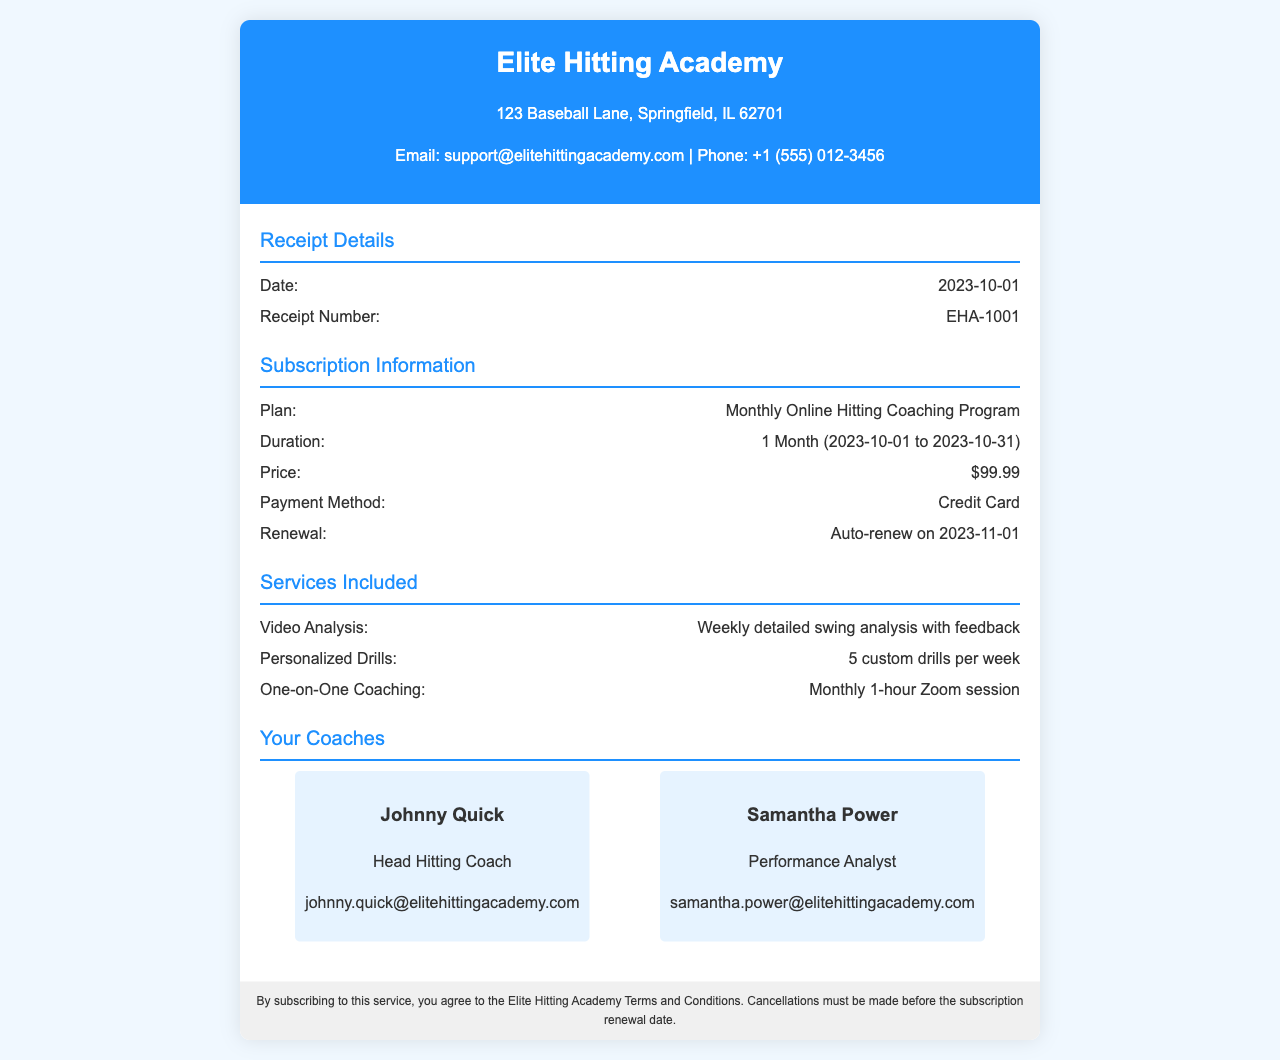what is the name of the academy? The academy's name is prominently displayed in the header section of the document.
Answer: Elite Hitting Academy what is the date of the receipt? The date can be found in the Receipt Details section of the document.
Answer: 2023-10-01 how much is the subscription price? The subscription price is listed under the Subscription Information section.
Answer: $99.99 who is the head hitting coach? The name of the head hitting coach is found in the Your Coaches section.
Answer: Johnny Quick what is included in the video analysis? The details about the video analysis are mentioned in the Services Included section.
Answer: Weekly detailed swing analysis with feedback how long is the subscription duration? The subscription duration is specified in the Subscription Information section.
Answer: 1 Month (2023-10-01 to 2023-10-31) what type of payment method is used? The payment method is stated clearly in the Subscription Information section of the document.
Answer: Credit Card when will the subscription auto-renew? The auto-renewal date is mentioned in the Subscription Information section.
Answer: 2023-11-01 how many custom drills are provided per week? The number of custom drills is stated in the Services Included section.
Answer: 5 custom drills per week 